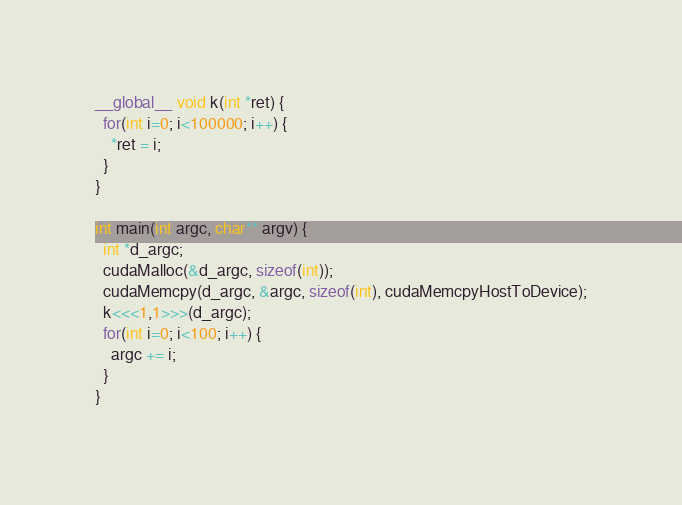Convert code to text. <code><loc_0><loc_0><loc_500><loc_500><_Cuda_>__global__ void k(int *ret) {
  for(int i=0; i<100000; i++) {
    *ret = i;
  }
}

int main(int argc, char** argv) {
  int *d_argc;
  cudaMalloc(&d_argc, sizeof(int));
  cudaMemcpy(d_argc, &argc, sizeof(int), cudaMemcpyHostToDevice);
  k<<<1,1>>>(d_argc);
  for(int i=0; i<100; i++) {
    argc += i;
  }
}
</code> 